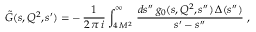Convert formula to latex. <formula><loc_0><loc_0><loc_500><loc_500>\tilde { G } ( s , Q ^ { 2 } , s ^ { \prime } ) = - \, \frac { 1 } { 2 \, \pi \, i } \int _ { 4 \, M ^ { 2 } } ^ { \infty } \, \frac { d s ^ { \prime \prime } \, g _ { 0 } ( s , Q ^ { 2 } , s ^ { \prime \prime } ) \, \Delta ( s ^ { \prime \prime } ) } { s ^ { \prime } - s ^ { \prime \prime } } \, ,</formula> 